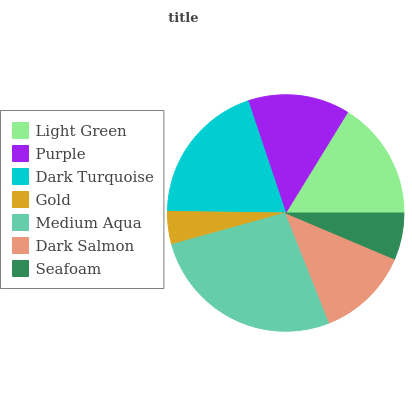Is Gold the minimum?
Answer yes or no. Yes. Is Medium Aqua the maximum?
Answer yes or no. Yes. Is Purple the minimum?
Answer yes or no. No. Is Purple the maximum?
Answer yes or no. No. Is Light Green greater than Purple?
Answer yes or no. Yes. Is Purple less than Light Green?
Answer yes or no. Yes. Is Purple greater than Light Green?
Answer yes or no. No. Is Light Green less than Purple?
Answer yes or no. No. Is Purple the high median?
Answer yes or no. Yes. Is Purple the low median?
Answer yes or no. Yes. Is Seafoam the high median?
Answer yes or no. No. Is Medium Aqua the low median?
Answer yes or no. No. 